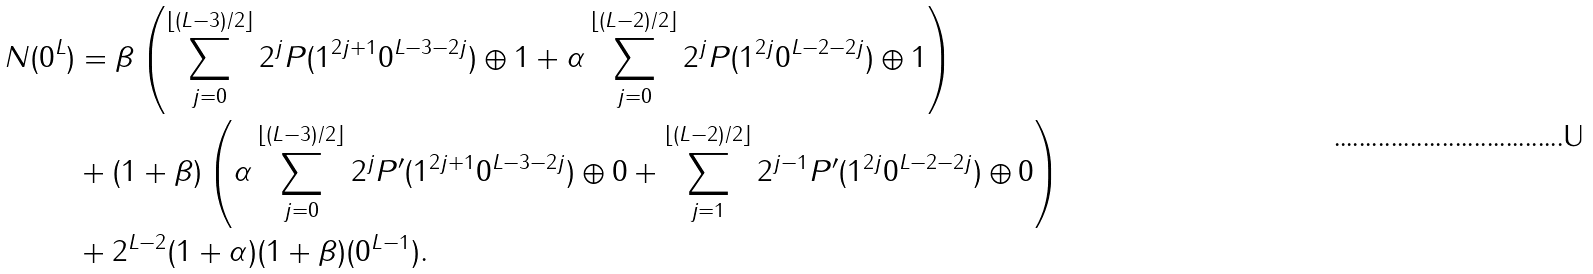<formula> <loc_0><loc_0><loc_500><loc_500>N ( 0 ^ { L } ) & = \beta \left ( \sum _ { j = 0 } ^ { \lfloor ( L - 3 ) / 2 \rfloor } 2 ^ { j } P ( 1 ^ { 2 j + 1 } 0 ^ { L - 3 - 2 j } ) \oplus 1 + \alpha \sum _ { j = 0 } ^ { \lfloor ( L - 2 ) / 2 \rfloor } 2 ^ { j } P ( 1 ^ { 2 j } 0 ^ { L - 2 - 2 j } ) \oplus 1 \right ) \\ & + ( 1 + \beta ) \left ( \alpha \sum _ { j = 0 } ^ { \lfloor ( L - 3 ) / 2 \rfloor } 2 ^ { j } P ^ { \prime } ( 1 ^ { 2 j + 1 } 0 ^ { L - 3 - 2 j } ) \oplus 0 + \sum _ { j = 1 } ^ { \lfloor ( L - 2 ) / 2 \rfloor } 2 ^ { j - 1 } P ^ { \prime } ( 1 ^ { 2 j } 0 ^ { L - 2 - 2 j } ) \oplus 0 \right ) \\ & + 2 ^ { L - 2 } ( 1 + \alpha ) ( 1 + \beta ) ( 0 ^ { L - 1 } ) .</formula> 